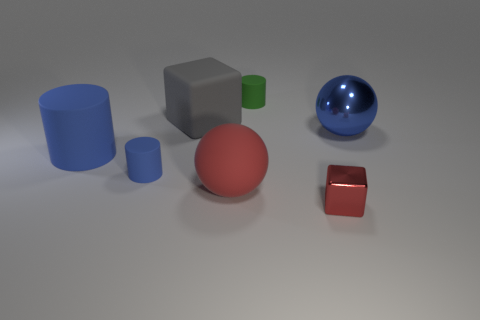What material is the tiny object that is both in front of the green cylinder and to the right of the red matte ball?
Ensure brevity in your answer.  Metal. Are the cylinder that is right of the gray rubber block and the large ball that is to the left of the blue metal thing made of the same material?
Your answer should be very brief. Yes. What size is the gray rubber object?
Offer a very short reply. Large. There is a shiny object that is the same shape as the red matte object; what is its size?
Offer a very short reply. Large. What number of tiny blue rubber cylinders are in front of the tiny blue cylinder?
Keep it short and to the point. 0. There is a tiny cylinder that is behind the small matte cylinder in front of the metal sphere; what is its color?
Keep it short and to the point. Green. Are there any other things that are the same shape as the large metal thing?
Make the answer very short. Yes. Are there the same number of red matte balls behind the tiny red metal thing and large gray matte cubes on the left side of the small blue matte cylinder?
Ensure brevity in your answer.  No. What number of spheres are either big metallic things or small green things?
Offer a terse response. 1. How many other things are made of the same material as the big red object?
Make the answer very short. 4. 